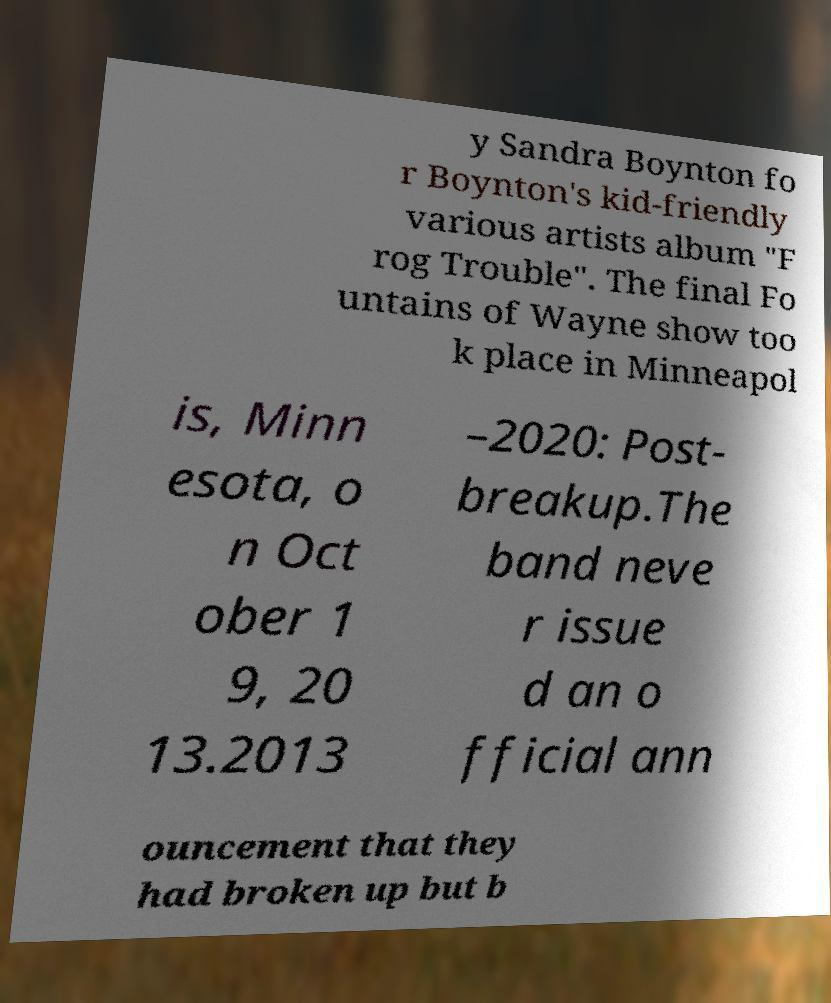For documentation purposes, I need the text within this image transcribed. Could you provide that? y Sandra Boynton fo r Boynton's kid-friendly various artists album "F rog Trouble". The final Fo untains of Wayne show too k place in Minneapol is, Minn esota, o n Oct ober 1 9, 20 13.2013 –2020: Post- breakup.The band neve r issue d an o fficial ann ouncement that they had broken up but b 